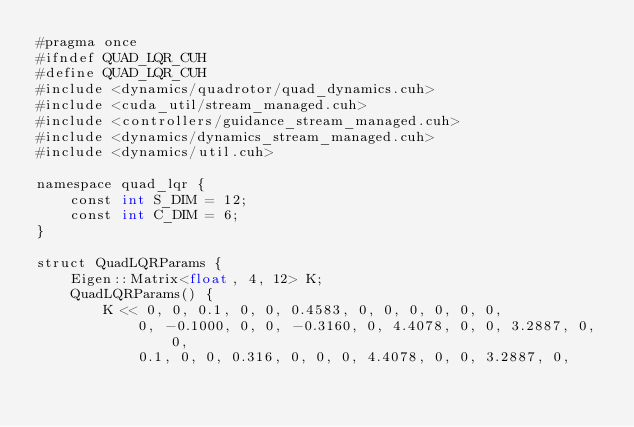<code> <loc_0><loc_0><loc_500><loc_500><_Cuda_>#pragma once
#ifndef QUAD_LQR_CUH
#define QUAD_LQR_CUH
#include <dynamics/quadrotor/quad_dynamics.cuh>
#include <cuda_util/stream_managed.cuh>
#include <controllers/guidance_stream_managed.cuh>
#include <dynamics/dynamics_stream_managed.cuh>
#include <dynamics/util.cuh>

namespace quad_lqr {
	const int S_DIM = 12;
	const int C_DIM = 6;
}

struct QuadLQRParams {
	Eigen::Matrix<float, 4, 12> K;
	QuadLQRParams() {
		K << 0, 0, 0.1, 0, 0, 0.4583, 0, 0, 0, 0, 0, 0,
			0, -0.1000, 0, 0, -0.3160, 0, 4.4078, 0, 0, 3.2887, 0, 0,
			0.1, 0, 0, 0.316, 0, 0, 0, 4.4078, 0, 0, 3.2887, 0,</code> 